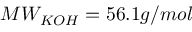Convert formula to latex. <formula><loc_0><loc_0><loc_500><loc_500>M W _ { K O H } = 5 6 . 1 g / m o l</formula> 